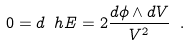<formula> <loc_0><loc_0><loc_500><loc_500>0 = d \ h E = 2 \frac { d \phi \wedge d V } { V ^ { 2 } } \ .</formula> 